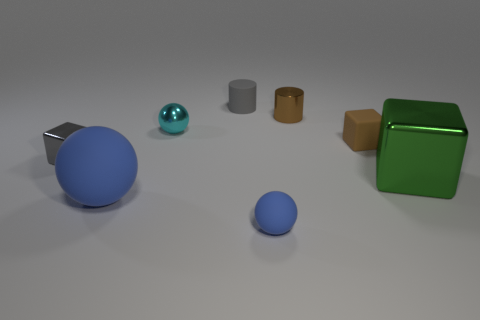Add 1 brown matte blocks. How many objects exist? 9 Subtract all cubes. How many objects are left? 5 Add 3 big green metallic blocks. How many big green metallic blocks are left? 4 Add 4 small yellow balls. How many small yellow balls exist? 4 Subtract 0 purple balls. How many objects are left? 8 Subtract all tiny brown cubes. Subtract all small gray metal objects. How many objects are left? 6 